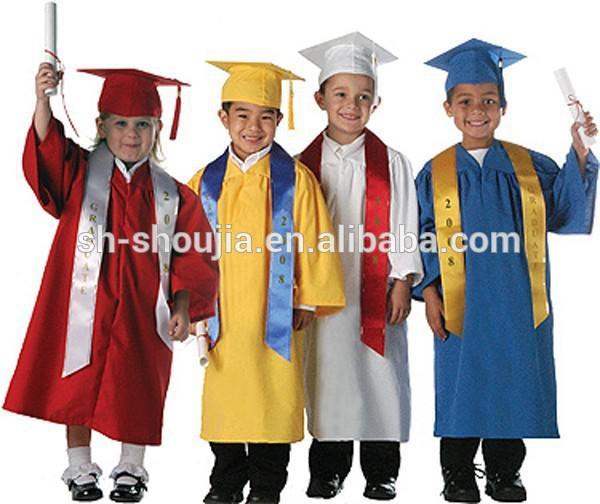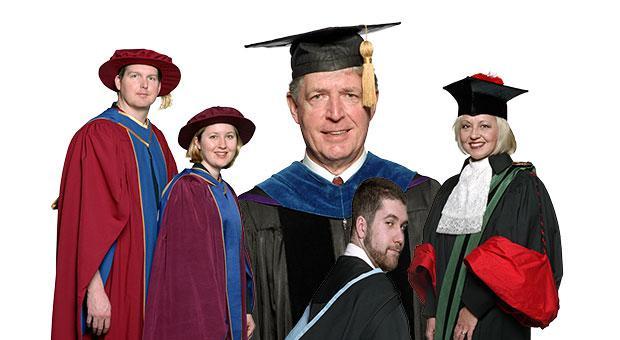The first image is the image on the left, the second image is the image on the right. For the images shown, is this caption "The left image contains exactly four children modeling four different colored graduation robes with matching hats, and two of them hold rolled white diplomas." true? Answer yes or no. Yes. The first image is the image on the left, the second image is the image on the right. Evaluate the accuracy of this statement regarding the images: "At least one person is wearing a white gown.". Is it true? Answer yes or no. Yes. 